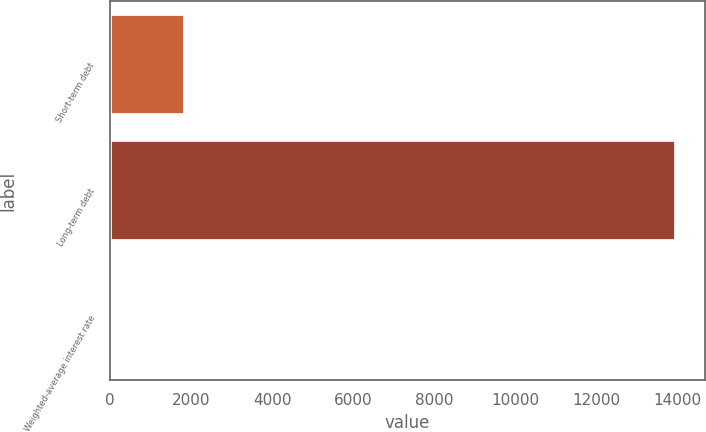Convert chart. <chart><loc_0><loc_0><loc_500><loc_500><bar_chart><fcel>Short-term debt<fcel>Long-term debt<fcel>Weighted-average interest rate<nl><fcel>1850<fcel>13980<fcel>2.7<nl></chart> 